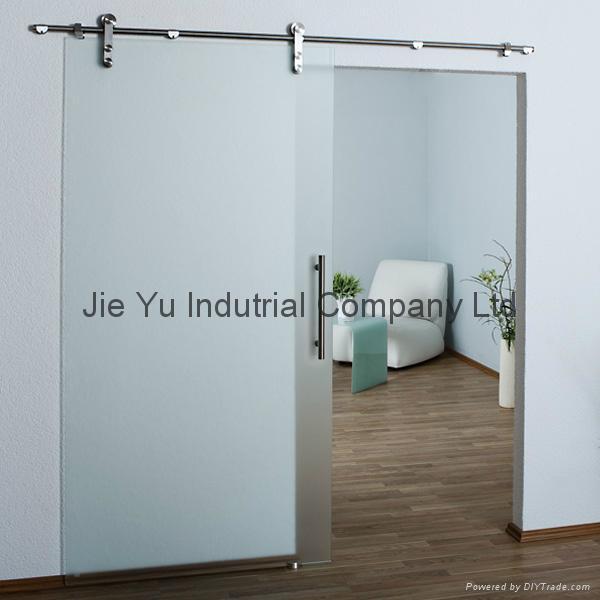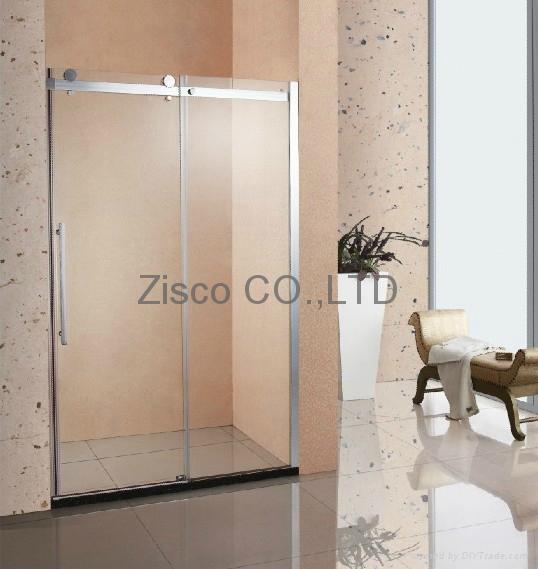The first image is the image on the left, the second image is the image on the right. For the images displayed, is the sentence "The image on the right contains a potted plant" factually correct? Answer yes or no. Yes. 